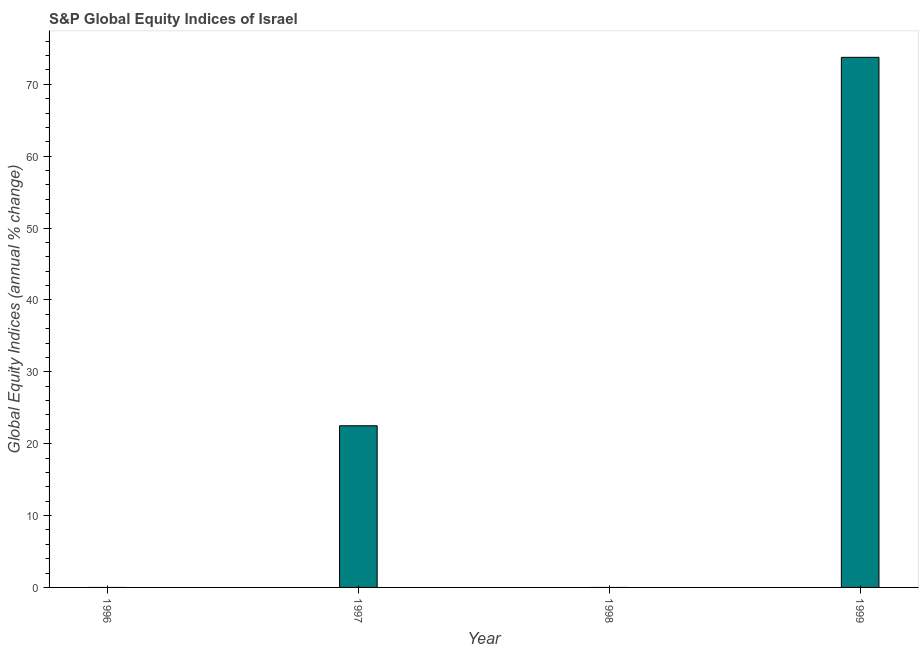What is the title of the graph?
Keep it short and to the point. S&P Global Equity Indices of Israel. What is the label or title of the Y-axis?
Ensure brevity in your answer.  Global Equity Indices (annual % change). Across all years, what is the maximum s&p global equity indices?
Keep it short and to the point. 73.76. Across all years, what is the minimum s&p global equity indices?
Keep it short and to the point. 0. What is the sum of the s&p global equity indices?
Ensure brevity in your answer.  96.26. What is the difference between the s&p global equity indices in 1997 and 1999?
Keep it short and to the point. -51.27. What is the average s&p global equity indices per year?
Offer a terse response. 24.06. What is the median s&p global equity indices?
Make the answer very short. 11.25. What is the ratio of the s&p global equity indices in 1997 to that in 1999?
Your answer should be very brief. 0.3. Is the sum of the s&p global equity indices in 1997 and 1999 greater than the maximum s&p global equity indices across all years?
Provide a succinct answer. Yes. What is the difference between the highest and the lowest s&p global equity indices?
Offer a terse response. 73.76. Are all the bars in the graph horizontal?
Ensure brevity in your answer.  No. How many years are there in the graph?
Give a very brief answer. 4. Are the values on the major ticks of Y-axis written in scientific E-notation?
Keep it short and to the point. No. What is the Global Equity Indices (annual % change) of 1996?
Your answer should be compact. 0. What is the Global Equity Indices (annual % change) in 1997?
Give a very brief answer. 22.5. What is the Global Equity Indices (annual % change) in 1999?
Your answer should be very brief. 73.76. What is the difference between the Global Equity Indices (annual % change) in 1997 and 1999?
Your answer should be very brief. -51.27. What is the ratio of the Global Equity Indices (annual % change) in 1997 to that in 1999?
Your answer should be very brief. 0.3. 